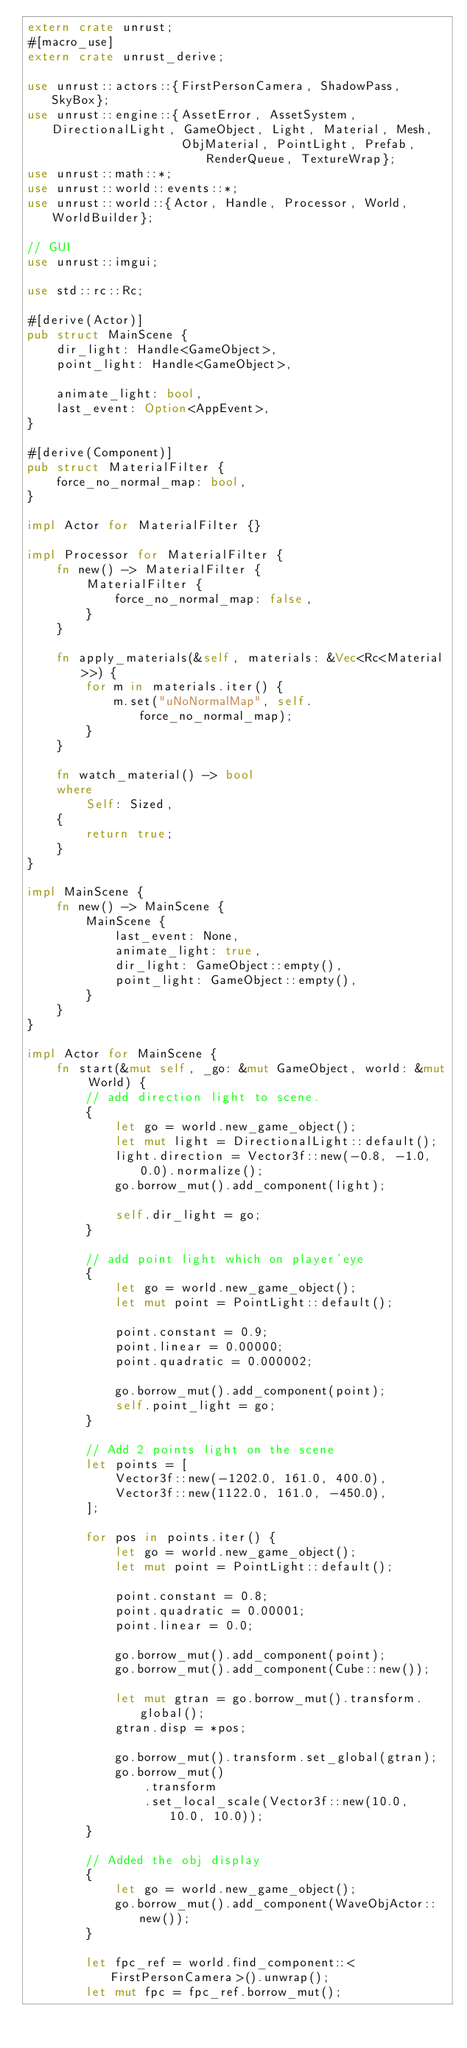<code> <loc_0><loc_0><loc_500><loc_500><_Rust_>extern crate unrust;
#[macro_use]
extern crate unrust_derive;

use unrust::actors::{FirstPersonCamera, ShadowPass, SkyBox};
use unrust::engine::{AssetError, AssetSystem, DirectionalLight, GameObject, Light, Material, Mesh,
                     ObjMaterial, PointLight, Prefab, RenderQueue, TextureWrap};
use unrust::math::*;
use unrust::world::events::*;
use unrust::world::{Actor, Handle, Processor, World, WorldBuilder};

// GUI
use unrust::imgui;

use std::rc::Rc;

#[derive(Actor)]
pub struct MainScene {
    dir_light: Handle<GameObject>,
    point_light: Handle<GameObject>,

    animate_light: bool,
    last_event: Option<AppEvent>,
}

#[derive(Component)]
pub struct MaterialFilter {
    force_no_normal_map: bool,
}

impl Actor for MaterialFilter {}

impl Processor for MaterialFilter {
    fn new() -> MaterialFilter {
        MaterialFilter {
            force_no_normal_map: false,
        }
    }

    fn apply_materials(&self, materials: &Vec<Rc<Material>>) {
        for m in materials.iter() {
            m.set("uNoNormalMap", self.force_no_normal_map);
        }
    }

    fn watch_material() -> bool
    where
        Self: Sized,
    {
        return true;
    }
}

impl MainScene {
    fn new() -> MainScene {
        MainScene {
            last_event: None,
            animate_light: true,
            dir_light: GameObject::empty(),
            point_light: GameObject::empty(),
        }
    }
}

impl Actor for MainScene {
    fn start(&mut self, _go: &mut GameObject, world: &mut World) {
        // add direction light to scene.
        {
            let go = world.new_game_object();
            let mut light = DirectionalLight::default();
            light.direction = Vector3f::new(-0.8, -1.0, 0.0).normalize();
            go.borrow_mut().add_component(light);

            self.dir_light = go;
        }

        // add point light which on player'eye
        {
            let go = world.new_game_object();
            let mut point = PointLight::default();

            point.constant = 0.9;
            point.linear = 0.00000;
            point.quadratic = 0.000002;

            go.borrow_mut().add_component(point);
            self.point_light = go;
        }

        // Add 2 points light on the scene
        let points = [
            Vector3f::new(-1202.0, 161.0, 400.0),
            Vector3f::new(1122.0, 161.0, -450.0),
        ];

        for pos in points.iter() {
            let go = world.new_game_object();
            let mut point = PointLight::default();

            point.constant = 0.8;
            point.quadratic = 0.00001;
            point.linear = 0.0;

            go.borrow_mut().add_component(point);
            go.borrow_mut().add_component(Cube::new());

            let mut gtran = go.borrow_mut().transform.global();
            gtran.disp = *pos;

            go.borrow_mut().transform.set_global(gtran);
            go.borrow_mut()
                .transform
                .set_local_scale(Vector3f::new(10.0, 10.0, 10.0));
        }

        // Added the obj display
        {
            let go = world.new_game_object();
            go.borrow_mut().add_component(WaveObjActor::new());
        }

        let fpc_ref = world.find_component::<FirstPersonCamera>().unwrap();
        let mut fpc = fpc_ref.borrow_mut();
</code> 